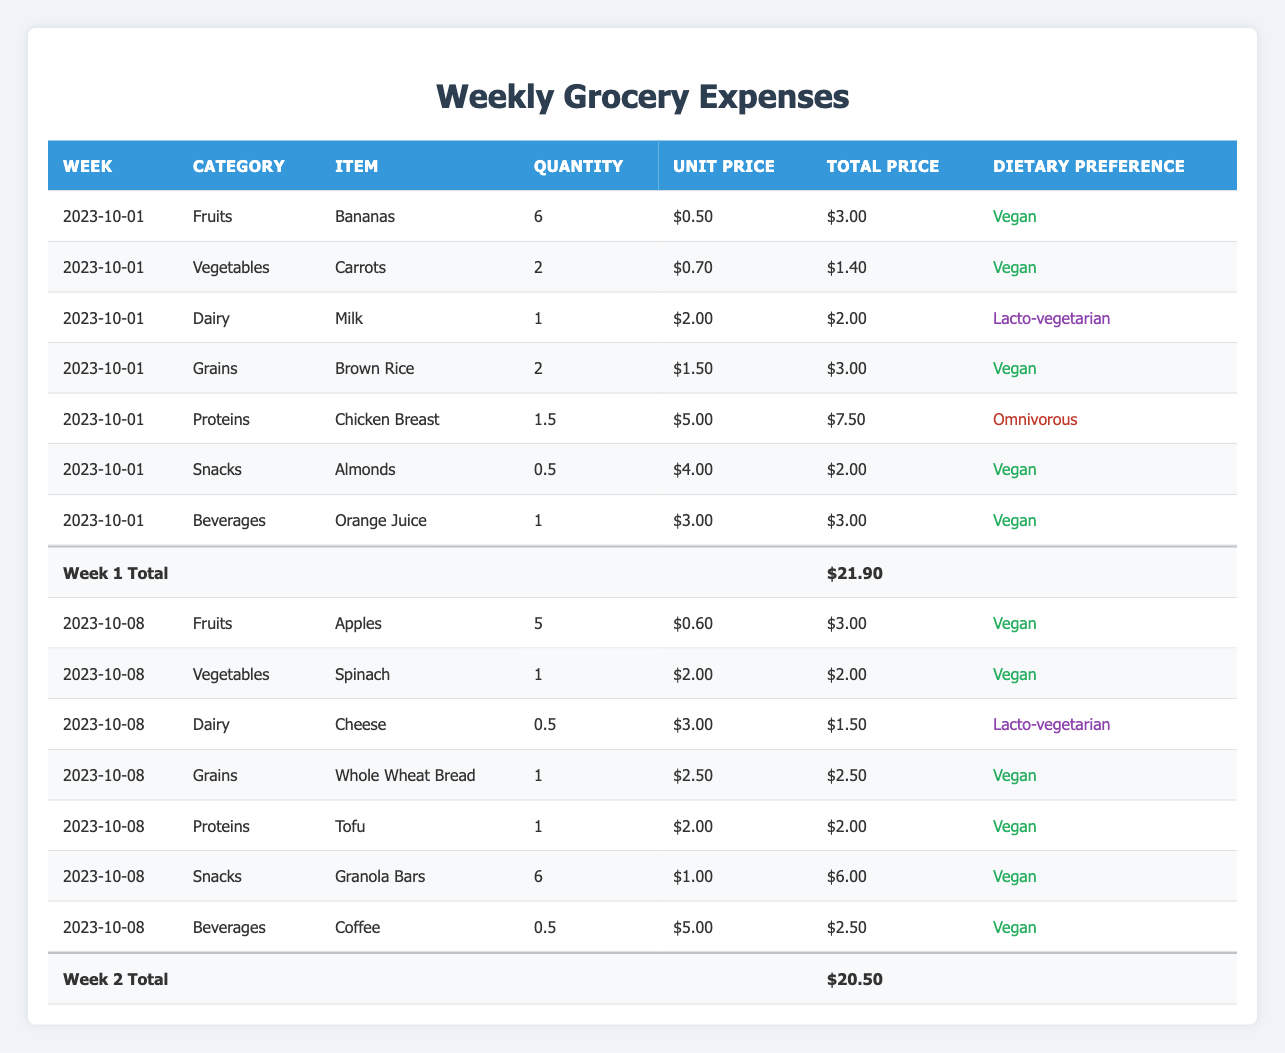What were the total grocery expenses for the week of 2023-10-01? The total expenses for the week of 2023-10-01 are listed in the table as $21.90.
Answer: $21.90 How much was spent on dairy products in the week of 2023-10-08? The dairy products are Cheese (total $1.50) in the week of 2023-10-08. Therefore, the total amount spent on dairy is $1.50.
Answer: $1.50 What is the total quantity of fruits purchased over the two weeks? For the first week, the quantity of bananas is 6, and for the second week, the quantity of apples is 5. Adding these gives 6 + 5 = 11.
Answer: 11 Did any items in the table have a unit price above $5.00? Yes, the Chicken Breast had a unit price of $5.00, but no items had a unit price above that.
Answer: No Which dietary preference had the highest total expenditure over the weeks? Summing the totals for each dietary preference reveals that Vegan items are the most purchased. Week 1: (Bananas $3.00 + Carrots $1.40 + Brown Rice $3.00 + Almonds $2.00 + Orange Juice $3.00) = $12.40; Week 2: (Apples $3.00 + Spinach $2.00 + Whole Wheat Bread $2.50 + Tofu $2.00 + Granola Bars $6.00 + Coffee $2.50) = $18.00. Overall, Vegan total = $12.40 + $18.00 = $30.40 is the highest.
Answer: Vegan What is the average total price of all snack items purchased across both weeks? For snacks: Week 1 (Almonds $2.00) and Week 2 (Granola Bars $6.00). Total snack expenses = $2.00 + $6.00 = $8.00 over 2 weeks. The average is $8.00 / 2 = $4.00.
Answer: $4.00 Is it true that all beverages purchased were vegan? Referencing the records, both beverages (Orange Juice and Coffee) indicate a dietary preference of Vegan. Thus, all beverages purchased were vegan.
Answer: Yes Which item had the highest total price in the week of 2023-10-01? The highest total price for that week is Chicken Breast at $7.50. After checking all items, this total exceeds all others.
Answer: Chicken Breast If I wanted to switch to only vegan foods, how much would I save from week 2 compared to the total spent? Total for week 2 is $20.50, vegan items only are (Apples $3.00 + Spinach $2.00 + Whole Wheat Bread $2.50 + Tofu $2.00 + Granola Bars $6.00 + Coffee $2.50) = $18.50. The savings would be $20.50 - $18.50 = $2.00.
Answer: $2.00 How many total items were purchased in the week of 2023-10-08? Summing the quantities from that week: Apples (5) + Spinach (1) + Cheese (0.5) + Whole Wheat Bread (1) + Tofu (1) + Granola Bars (6) + Coffee (0.5) gives a total of 5 + 1 + 0.5 + 1 + 1 + 6 + 0.5 = 15.
Answer: 15 What was the total expense on proteins across both weeks? Proteins in week 1: Chicken Breast $7.50. In week 2: Tofu $2.00. The total is $7.50 + $2.00 = $9.50.
Answer: $9.50 